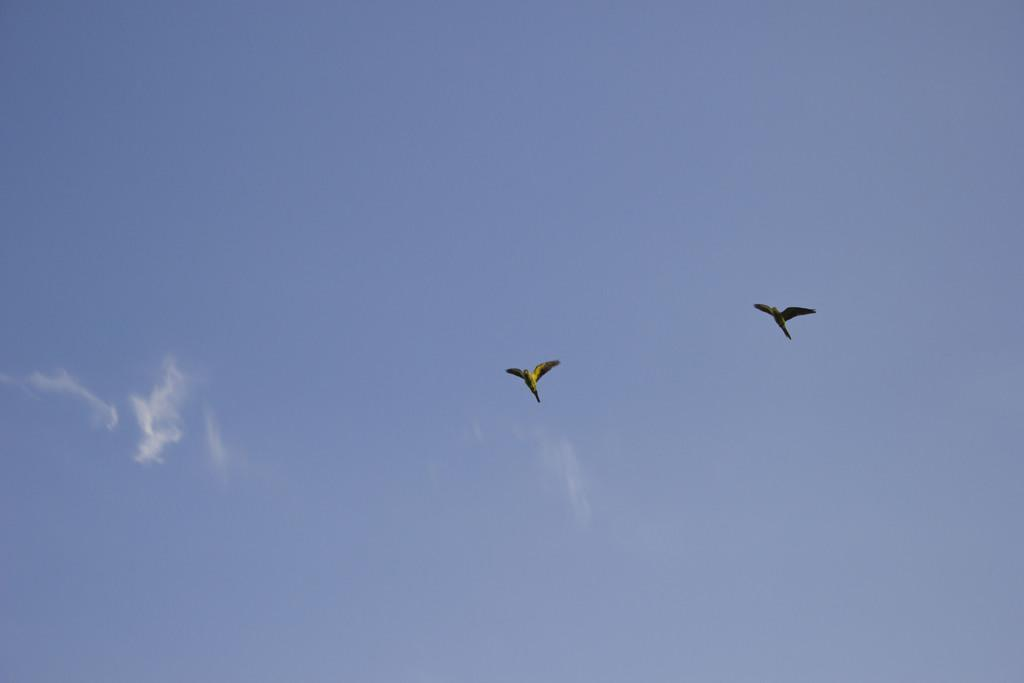What is happening in the image involving birds? There are two birds flying in the image. Where are the birds located in the image? The birds are in the sky. What else can be seen in the sky in the image? Clouds are present in the sky. How much of the sky is visible in the image? The sky is visible in the image. What type of poison is being used by the birds in the image? There is no poison present in the image; it features two birds flying in the sky. What stage of development is the star in the image? There is no star present in the image; it only features birds and clouds in the sky. 